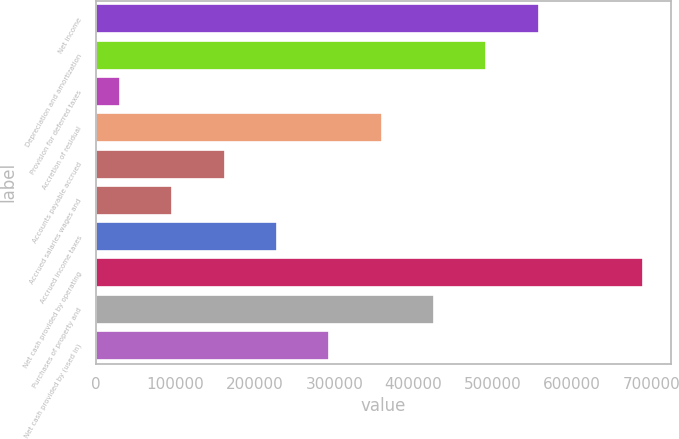Convert chart to OTSL. <chart><loc_0><loc_0><loc_500><loc_500><bar_chart><fcel>Net income<fcel>Depreciation and amortization<fcel>Provision for deferred taxes<fcel>Accretion of residual<fcel>Accounts payable accrued<fcel>Accrued salaries wages and<fcel>Accrued income taxes<fcel>Net cash provided by operating<fcel>Purchases of property and<fcel>Net cash provided by (used in)<nl><fcel>557777<fcel>491798<fcel>29944<fcel>359840<fcel>161902<fcel>95923.1<fcel>227881<fcel>689735<fcel>425819<fcel>293860<nl></chart> 